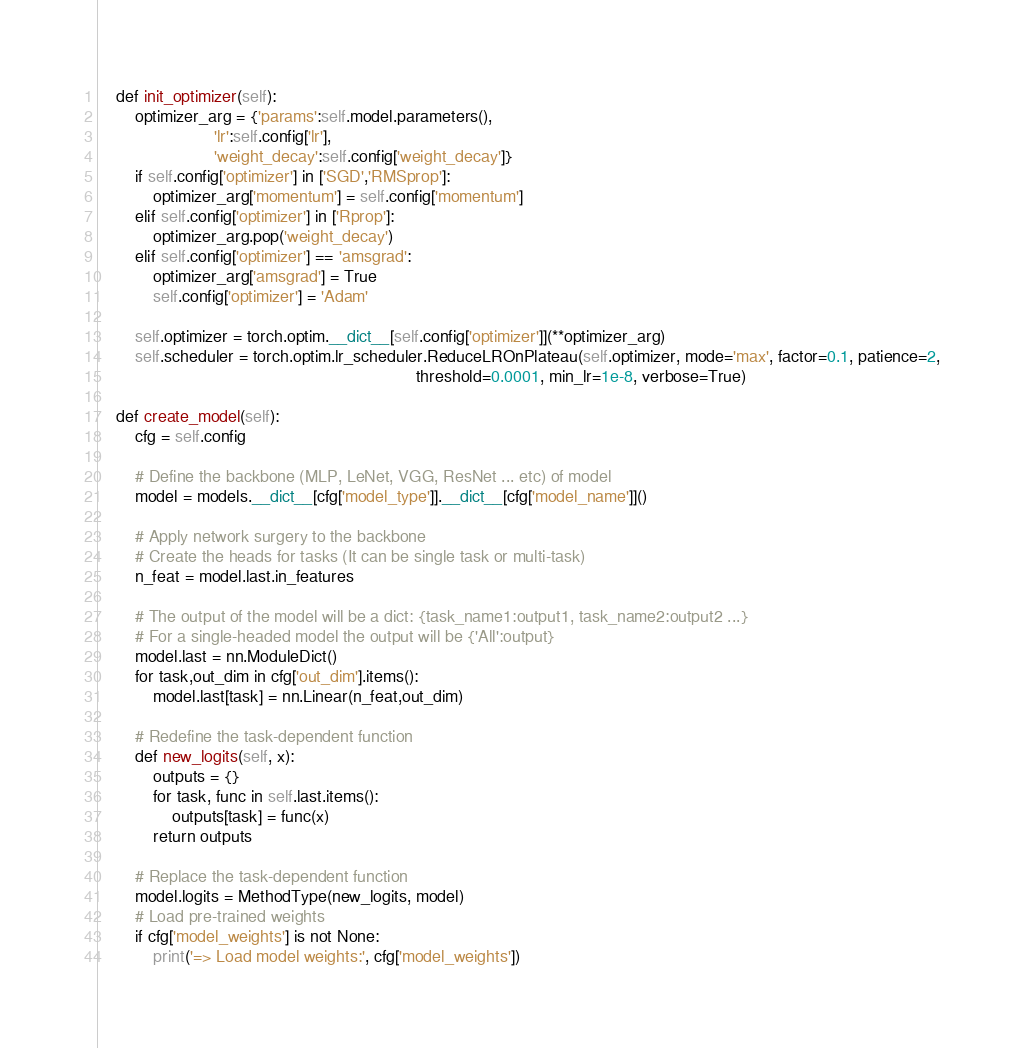Convert code to text. <code><loc_0><loc_0><loc_500><loc_500><_Python_>    def init_optimizer(self):
        optimizer_arg = {'params':self.model.parameters(),
                         'lr':self.config['lr'],
                         'weight_decay':self.config['weight_decay']}
        if self.config['optimizer'] in ['SGD','RMSprop']:
            optimizer_arg['momentum'] = self.config['momentum']
        elif self.config['optimizer'] in ['Rprop']:
            optimizer_arg.pop('weight_decay')
        elif self.config['optimizer'] == 'amsgrad':
            optimizer_arg['amsgrad'] = True
            self.config['optimizer'] = 'Adam'

        self.optimizer = torch.optim.__dict__[self.config['optimizer']](**optimizer_arg)
        self.scheduler = torch.optim.lr_scheduler.ReduceLROnPlateau(self.optimizer, mode='max', factor=0.1, patience=2,
                                                                    threshold=0.0001, min_lr=1e-8, verbose=True)

    def create_model(self):
        cfg = self.config

        # Define the backbone (MLP, LeNet, VGG, ResNet ... etc) of model
        model = models.__dict__[cfg['model_type']].__dict__[cfg['model_name']]()

        # Apply network surgery to the backbone
        # Create the heads for tasks (It can be single task or multi-task)
        n_feat = model.last.in_features

        # The output of the model will be a dict: {task_name1:output1, task_name2:output2 ...}
        # For a single-headed model the output will be {'All':output}
        model.last = nn.ModuleDict()
        for task,out_dim in cfg['out_dim'].items():
            model.last[task] = nn.Linear(n_feat,out_dim)

        # Redefine the task-dependent function
        def new_logits(self, x):
            outputs = {}
            for task, func in self.last.items():
                outputs[task] = func(x)
            return outputs

        # Replace the task-dependent function
        model.logits = MethodType(new_logits, model)
        # Load pre-trained weights
        if cfg['model_weights'] is not None:
            print('=> Load model weights:', cfg['model_weights'])</code> 